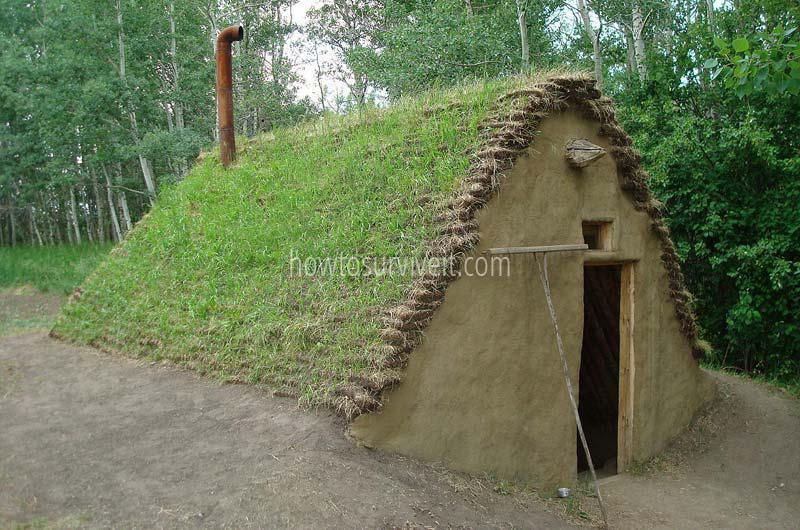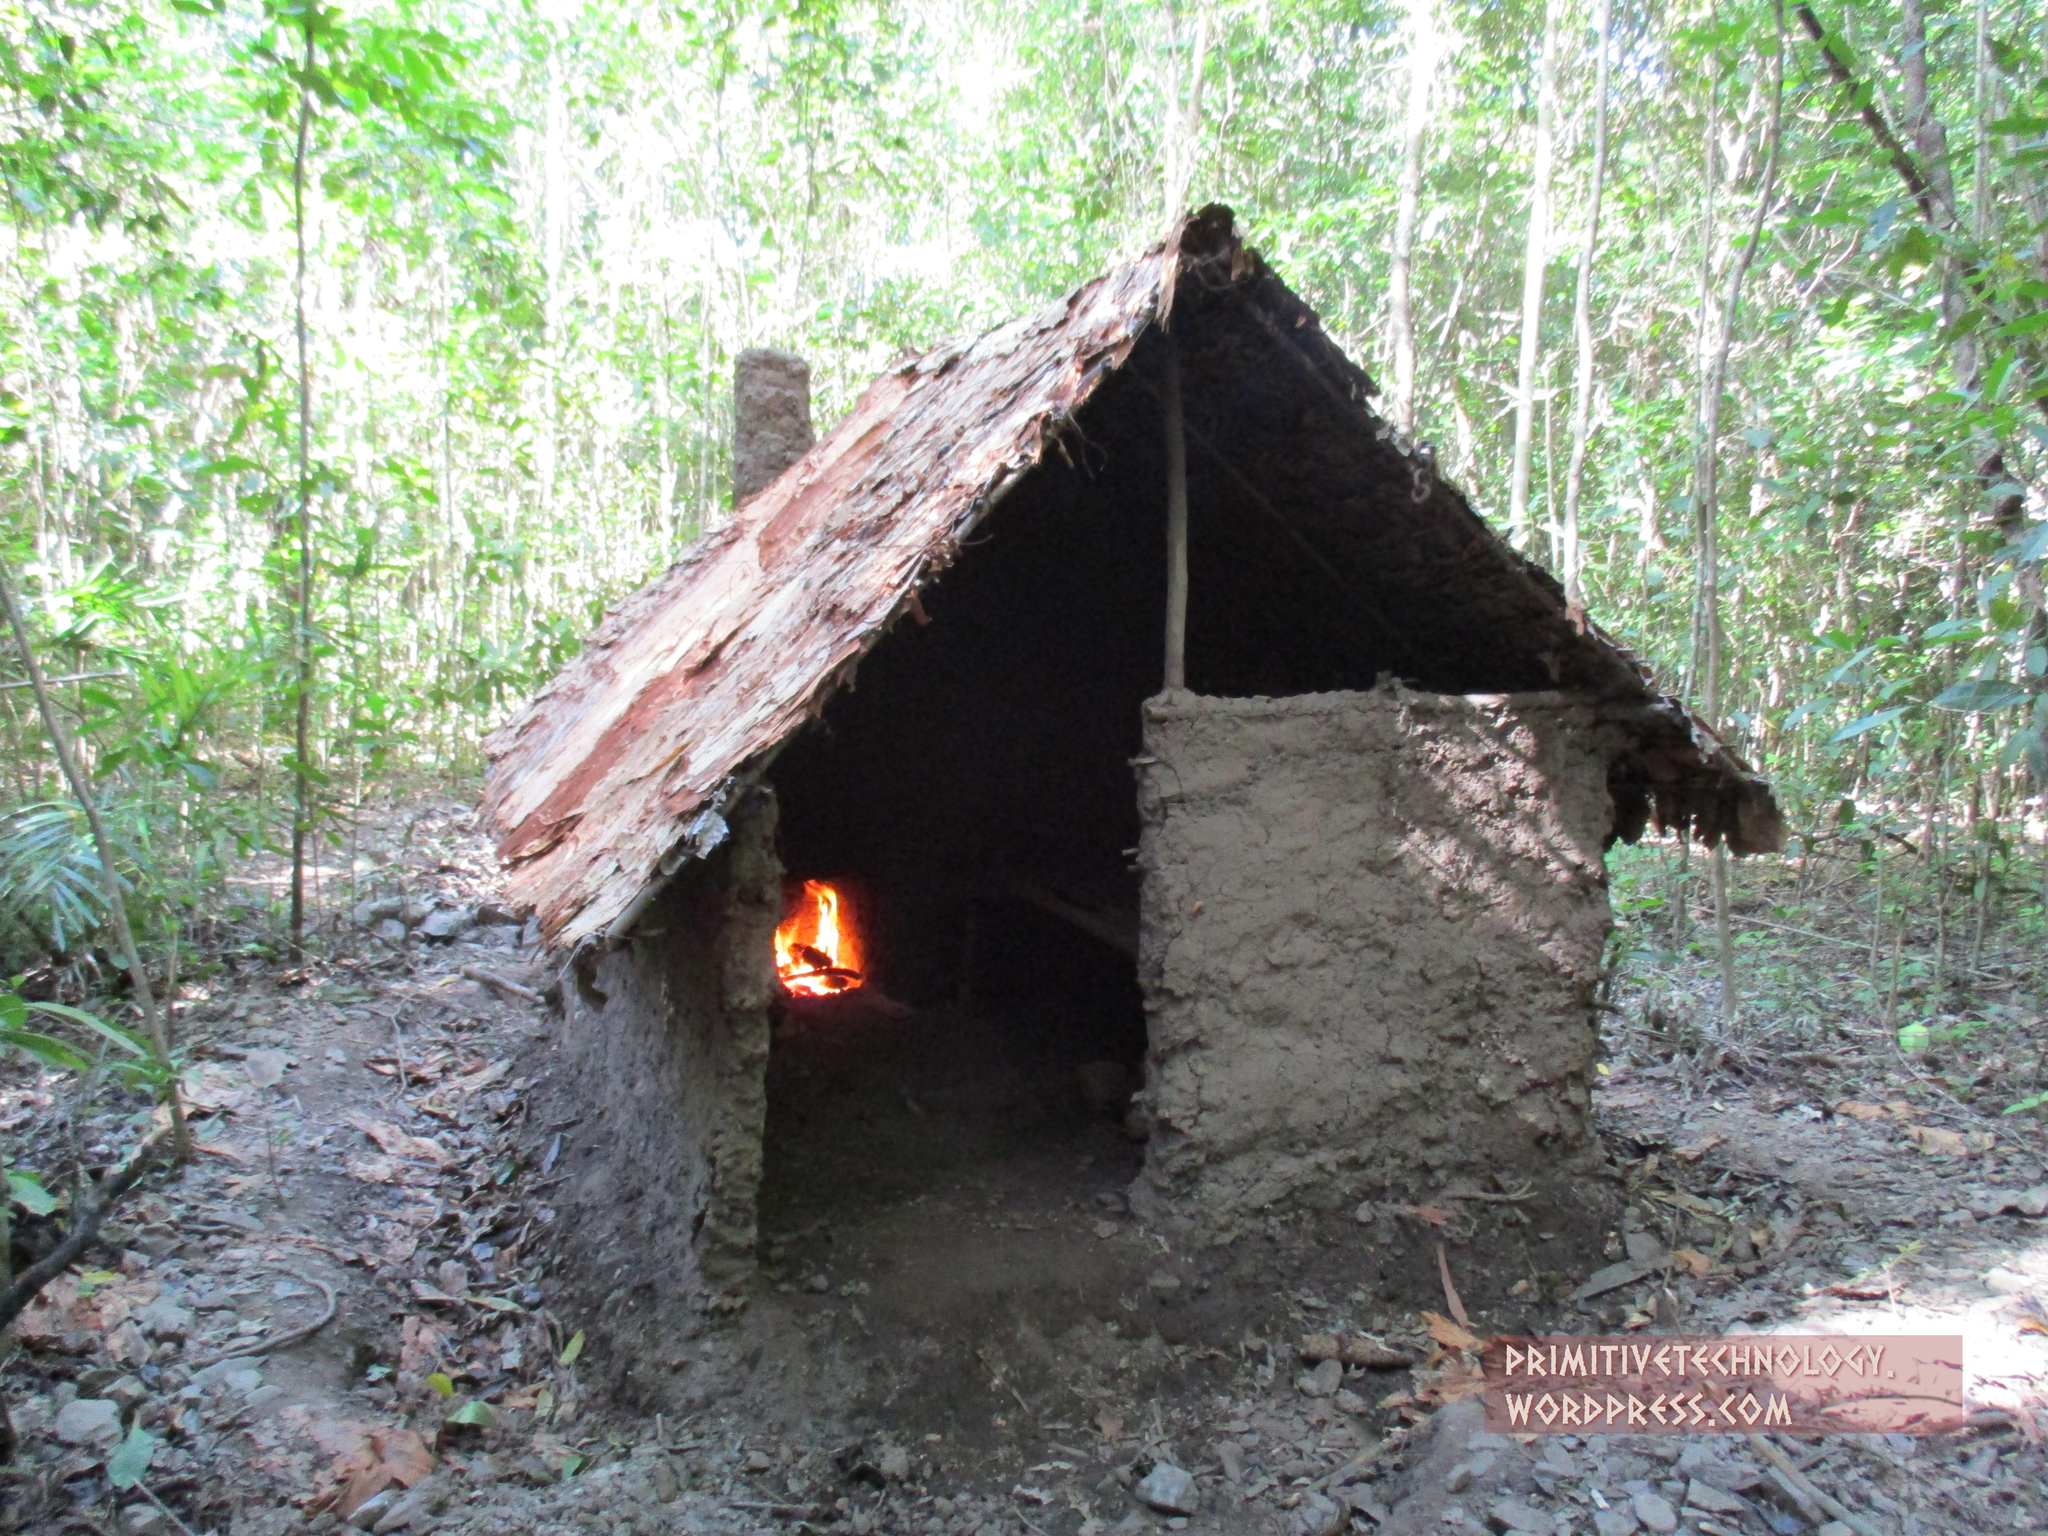The first image is the image on the left, the second image is the image on the right. For the images shown, is this caption "None of the shelters have a door." true? Answer yes or no. Yes. 